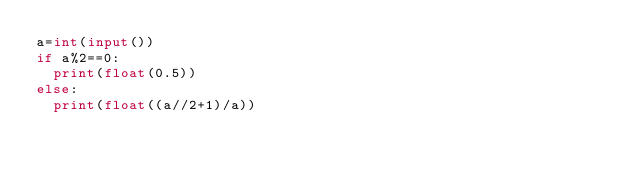<code> <loc_0><loc_0><loc_500><loc_500><_Python_>a=int(input())
if a%2==0:
  print(float(0.5))
else:
  print(float((a//2+1)/a))</code> 